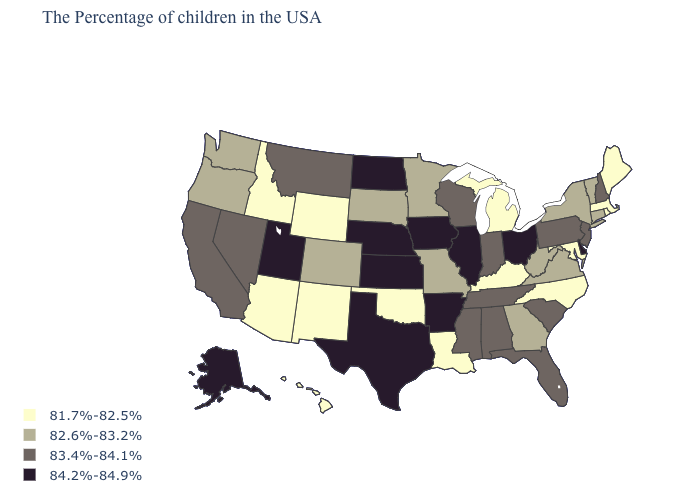Does the map have missing data?
Short answer required. No. Name the states that have a value in the range 82.6%-83.2%?
Answer briefly. Vermont, Connecticut, New York, Virginia, West Virginia, Georgia, Missouri, Minnesota, South Dakota, Colorado, Washington, Oregon. Which states have the lowest value in the Northeast?
Keep it brief. Maine, Massachusetts, Rhode Island. Does the first symbol in the legend represent the smallest category?
Concise answer only. Yes. Which states have the highest value in the USA?
Quick response, please. Delaware, Ohio, Illinois, Arkansas, Iowa, Kansas, Nebraska, Texas, North Dakota, Utah, Alaska. What is the value of Washington?
Concise answer only. 82.6%-83.2%. Name the states that have a value in the range 84.2%-84.9%?
Be succinct. Delaware, Ohio, Illinois, Arkansas, Iowa, Kansas, Nebraska, Texas, North Dakota, Utah, Alaska. What is the value of Connecticut?
Short answer required. 82.6%-83.2%. Does Arkansas have the highest value in the USA?
Give a very brief answer. Yes. Does the map have missing data?
Give a very brief answer. No. Does Nebraska have the highest value in the MidWest?
Answer briefly. Yes. Does the map have missing data?
Write a very short answer. No. What is the lowest value in states that border New Hampshire?
Give a very brief answer. 81.7%-82.5%. What is the lowest value in the MidWest?
Keep it brief. 81.7%-82.5%. Name the states that have a value in the range 82.6%-83.2%?
Concise answer only. Vermont, Connecticut, New York, Virginia, West Virginia, Georgia, Missouri, Minnesota, South Dakota, Colorado, Washington, Oregon. 